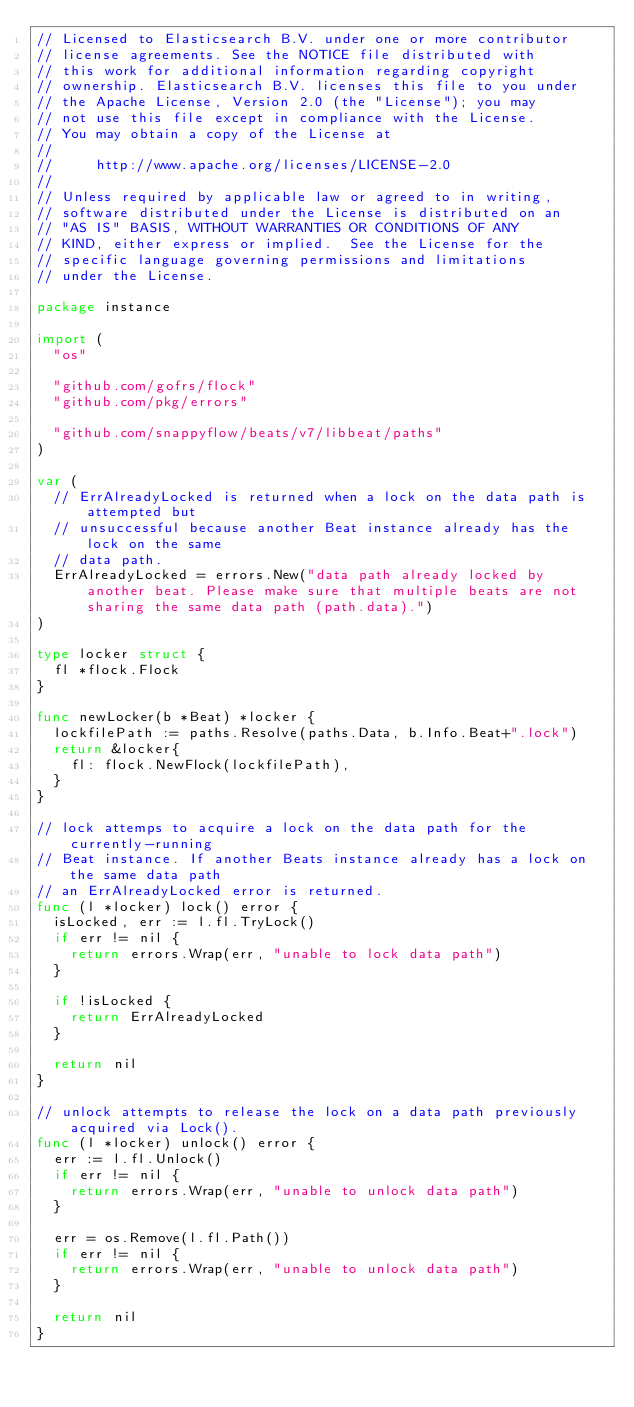<code> <loc_0><loc_0><loc_500><loc_500><_Go_>// Licensed to Elasticsearch B.V. under one or more contributor
// license agreements. See the NOTICE file distributed with
// this work for additional information regarding copyright
// ownership. Elasticsearch B.V. licenses this file to you under
// the Apache License, Version 2.0 (the "License"); you may
// not use this file except in compliance with the License.
// You may obtain a copy of the License at
//
//     http://www.apache.org/licenses/LICENSE-2.0
//
// Unless required by applicable law or agreed to in writing,
// software distributed under the License is distributed on an
// "AS IS" BASIS, WITHOUT WARRANTIES OR CONDITIONS OF ANY
// KIND, either express or implied.  See the License for the
// specific language governing permissions and limitations
// under the License.

package instance

import (
	"os"

	"github.com/gofrs/flock"
	"github.com/pkg/errors"

	"github.com/snappyflow/beats/v7/libbeat/paths"
)

var (
	// ErrAlreadyLocked is returned when a lock on the data path is attempted but
	// unsuccessful because another Beat instance already has the lock on the same
	// data path.
	ErrAlreadyLocked = errors.New("data path already locked by another beat. Please make sure that multiple beats are not sharing the same data path (path.data).")
)

type locker struct {
	fl *flock.Flock
}

func newLocker(b *Beat) *locker {
	lockfilePath := paths.Resolve(paths.Data, b.Info.Beat+".lock")
	return &locker{
		fl: flock.NewFlock(lockfilePath),
	}
}

// lock attemps to acquire a lock on the data path for the currently-running
// Beat instance. If another Beats instance already has a lock on the same data path
// an ErrAlreadyLocked error is returned.
func (l *locker) lock() error {
	isLocked, err := l.fl.TryLock()
	if err != nil {
		return errors.Wrap(err, "unable to lock data path")
	}

	if !isLocked {
		return ErrAlreadyLocked
	}

	return nil
}

// unlock attempts to release the lock on a data path previously acquired via Lock().
func (l *locker) unlock() error {
	err := l.fl.Unlock()
	if err != nil {
		return errors.Wrap(err, "unable to unlock data path")
	}

	err = os.Remove(l.fl.Path())
	if err != nil {
		return errors.Wrap(err, "unable to unlock data path")
	}

	return nil
}
</code> 